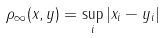Convert formula to latex. <formula><loc_0><loc_0><loc_500><loc_500>\rho _ { \infty } ( x , y ) = \sup _ { i } \left | x _ { i } - y _ { i } \right |</formula> 